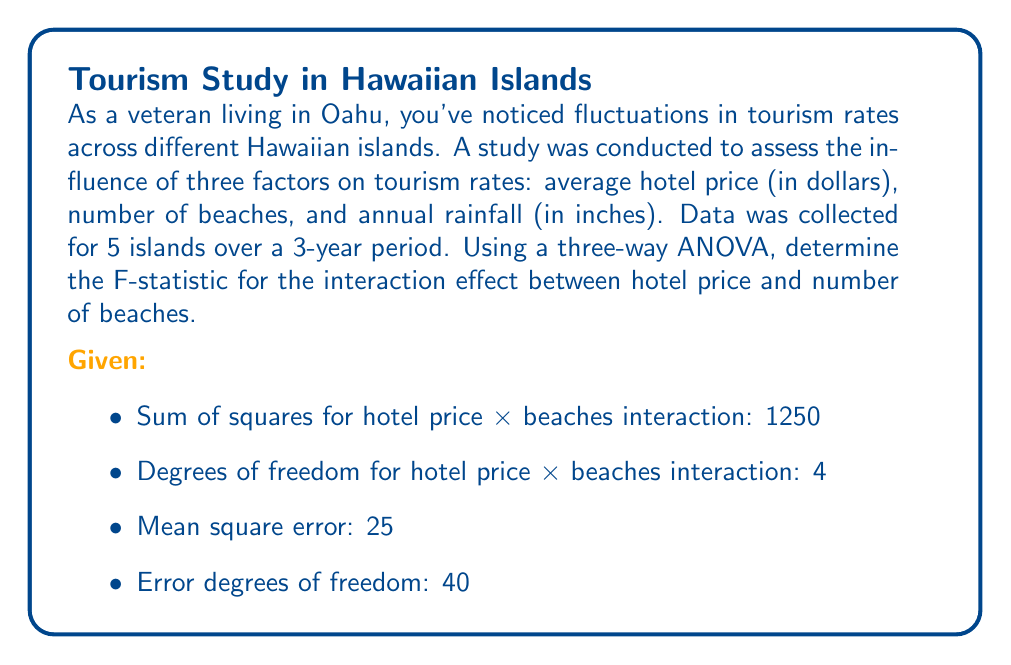Give your solution to this math problem. To solve this problem, we'll follow these steps:

1) First, recall the formula for the F-statistic in ANOVA:

   $$F = \frac{MS_{effect}}{MS_{error}}$$

   Where $MS_{effect}$ is the mean square for the effect we're interested in, and $MS_{error}$ is the mean square error.

2) We're given the mean square error ($MS_{error} = 25$) and the error degrees of freedom (40).

3) We need to calculate the mean square for the hotel price × beaches interaction ($MS_{HB}$). The formula for this is:

   $$MS_{HB} = \frac{SS_{HB}}{df_{HB}}$$

   Where $SS_{HB}$ is the sum of squares for the interaction and $df_{HB}$ is the degrees of freedom for the interaction.

4) We're given both of these values:
   $SS_{HB} = 1250$
   $df_{HB} = 4$

5) Let's calculate $MS_{HB}$:

   $$MS_{HB} = \frac{1250}{4} = 312.5$$

6) Now we can calculate the F-statistic:

   $$F = \frac{MS_{HB}}{MS_{error}} = \frac{312.5}{25} = 12.5$$

Therefore, the F-statistic for the interaction effect between hotel price and number of beaches is 12.5.
Answer: $F = 12.5$ 